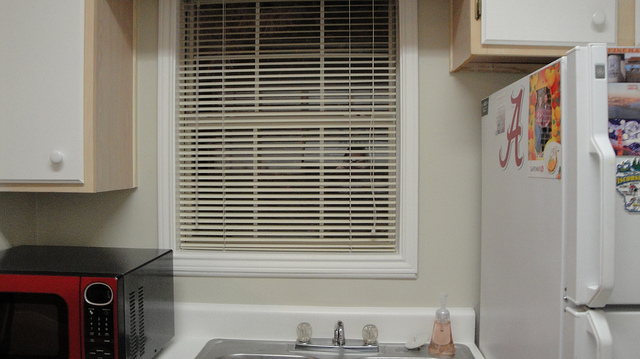Please extract the text content from this image. A 